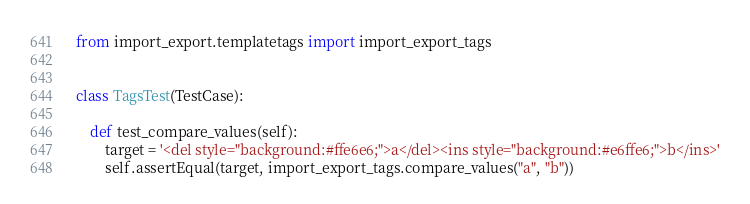<code> <loc_0><loc_0><loc_500><loc_500><_Python_>
from import_export.templatetags import import_export_tags


class TagsTest(TestCase):

    def test_compare_values(self):
        target = '<del style="background:#ffe6e6;">a</del><ins style="background:#e6ffe6;">b</ins>'
        self.assertEqual(target, import_export_tags.compare_values("a", "b"))</code> 